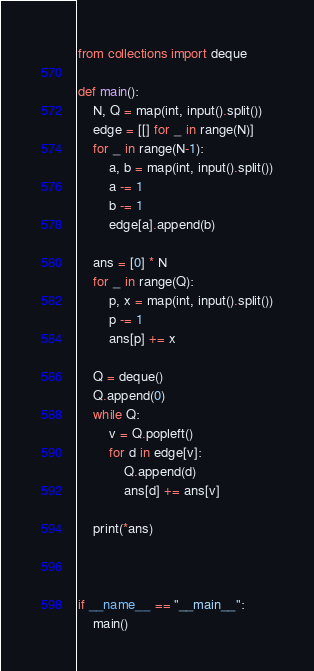<code> <loc_0><loc_0><loc_500><loc_500><_Python_>from collections import deque

def main():
    N, Q = map(int, input().split())
    edge = [[] for _ in range(N)]
    for _ in range(N-1):
        a, b = map(int, input().split())
        a -= 1
        b -= 1
        edge[a].append(b)
        
    ans = [0] * N
    for _ in range(Q):
        p, x = map(int, input().split())
        p -= 1 
        ans[p] += x
    
    Q = deque()
    Q.append(0)
    while Q:
        v = Q.popleft()
        for d in edge[v]:
            Q.append(d)
            ans[d] += ans[v]

    print(*ans)



if __name__ == "__main__":
    main()</code> 